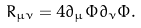<formula> <loc_0><loc_0><loc_500><loc_500>R _ { \mu \nu } = 4 \partial _ { \mu } \Phi \partial _ { \nu } \Phi .</formula> 